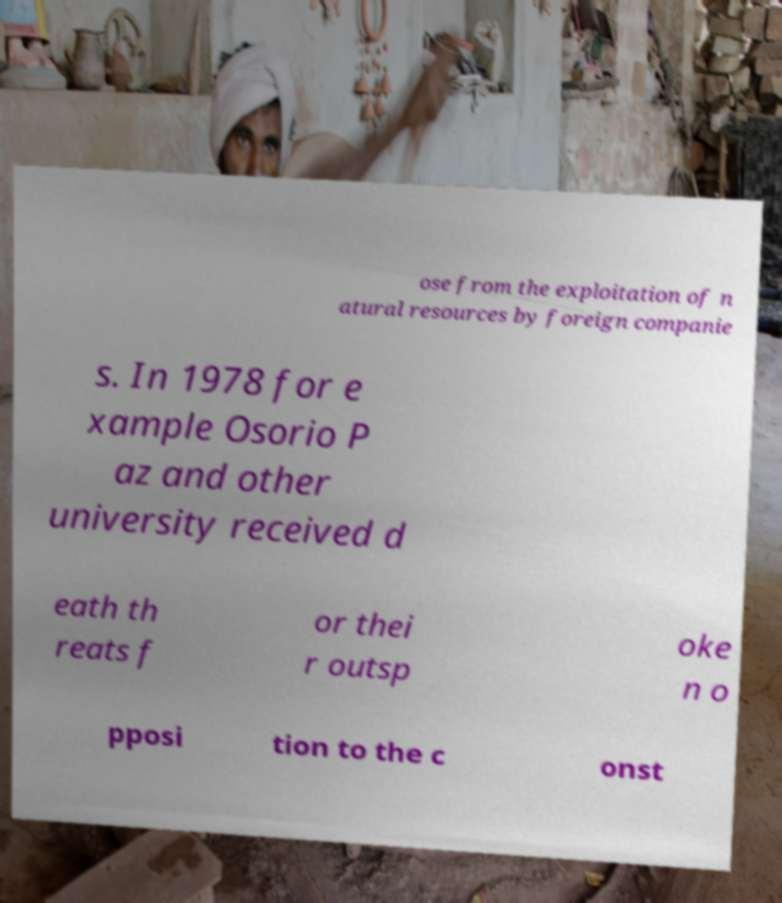Could you extract and type out the text from this image? ose from the exploitation of n atural resources by foreign companie s. In 1978 for e xample Osorio P az and other university received d eath th reats f or thei r outsp oke n o pposi tion to the c onst 